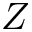<formula> <loc_0><loc_0><loc_500><loc_500>Z</formula> 